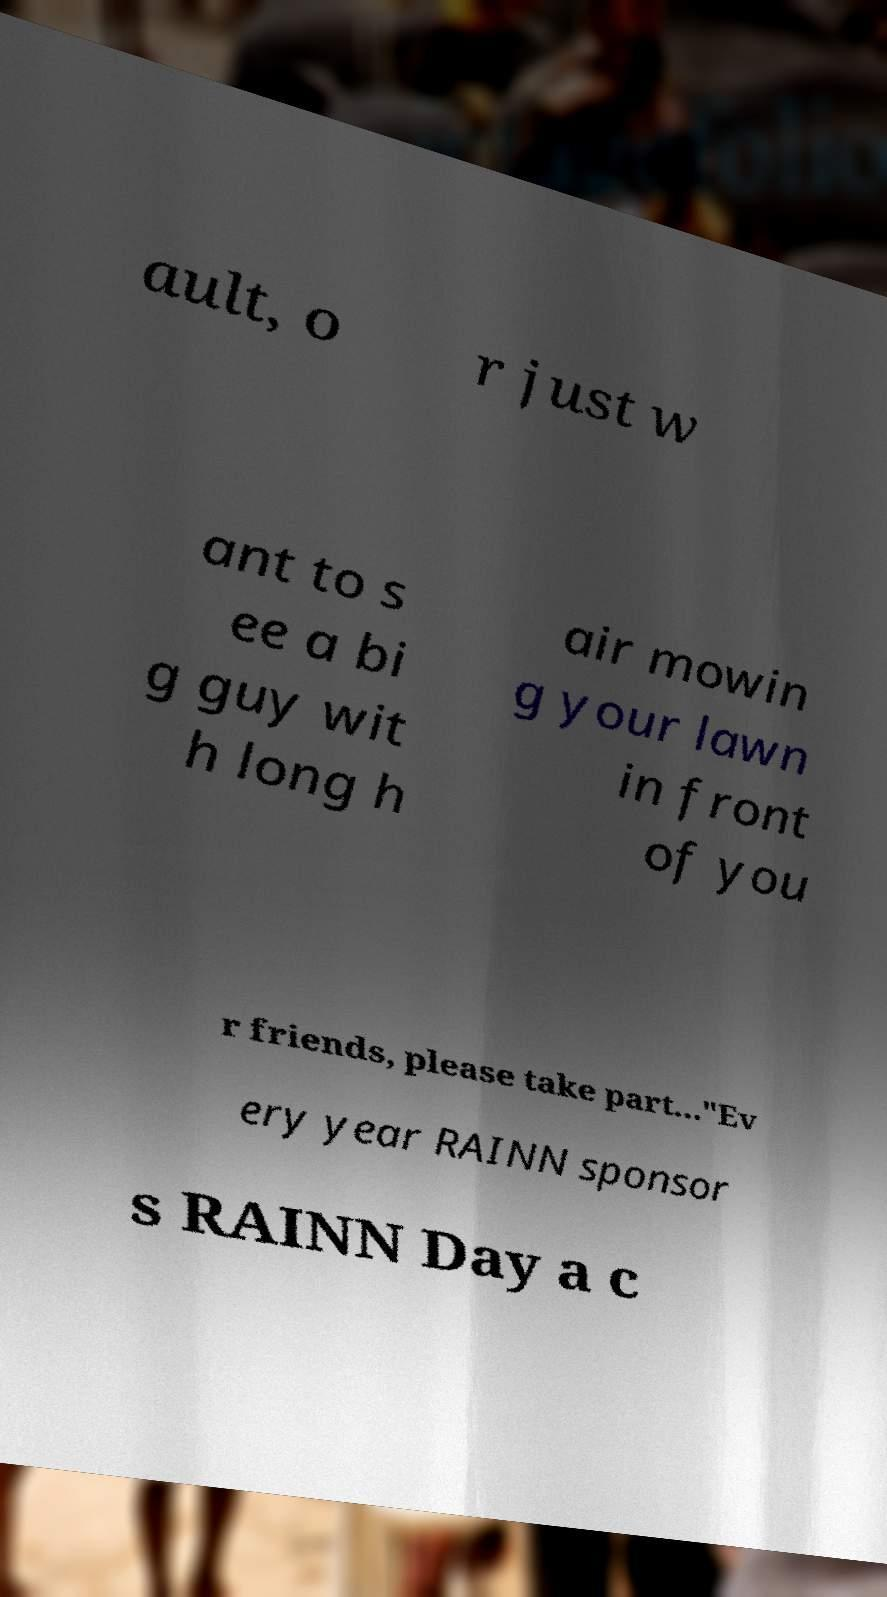Please read and relay the text visible in this image. What does it say? ault, o r just w ant to s ee a bi g guy wit h long h air mowin g your lawn in front of you r friends, please take part..."Ev ery year RAINN sponsor s RAINN Day a c 